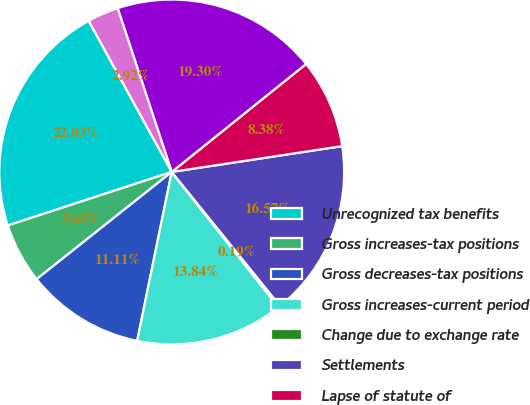Convert chart. <chart><loc_0><loc_0><loc_500><loc_500><pie_chart><fcel>Unrecognized tax benefits<fcel>Gross increases-tax positions<fcel>Gross decreases-tax positions<fcel>Gross increases-current period<fcel>Change due to exchange rate<fcel>Settlements<fcel>Lapse of statute of<fcel>Interest<fcel>Penalties<nl><fcel>22.03%<fcel>5.65%<fcel>11.11%<fcel>13.84%<fcel>0.19%<fcel>16.57%<fcel>8.38%<fcel>19.3%<fcel>2.92%<nl></chart> 